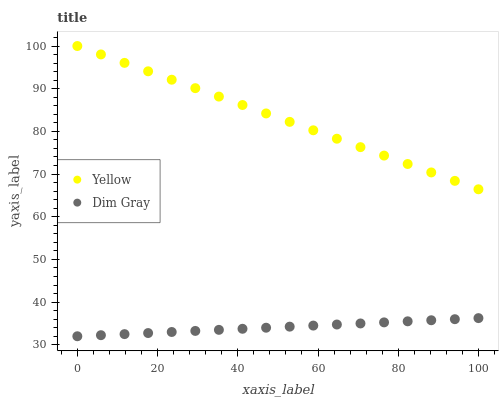Does Dim Gray have the minimum area under the curve?
Answer yes or no. Yes. Does Yellow have the maximum area under the curve?
Answer yes or no. Yes. Does Yellow have the minimum area under the curve?
Answer yes or no. No. Is Dim Gray the smoothest?
Answer yes or no. Yes. Is Yellow the roughest?
Answer yes or no. Yes. Is Yellow the smoothest?
Answer yes or no. No. Does Dim Gray have the lowest value?
Answer yes or no. Yes. Does Yellow have the lowest value?
Answer yes or no. No. Does Yellow have the highest value?
Answer yes or no. Yes. Is Dim Gray less than Yellow?
Answer yes or no. Yes. Is Yellow greater than Dim Gray?
Answer yes or no. Yes. Does Dim Gray intersect Yellow?
Answer yes or no. No. 